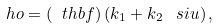<formula> <loc_0><loc_0><loc_500><loc_500>\ h o = ( \ t h b f ) \, ( k _ { 1 } + k _ { 2 } \, \ s i u ) \, ,</formula> 